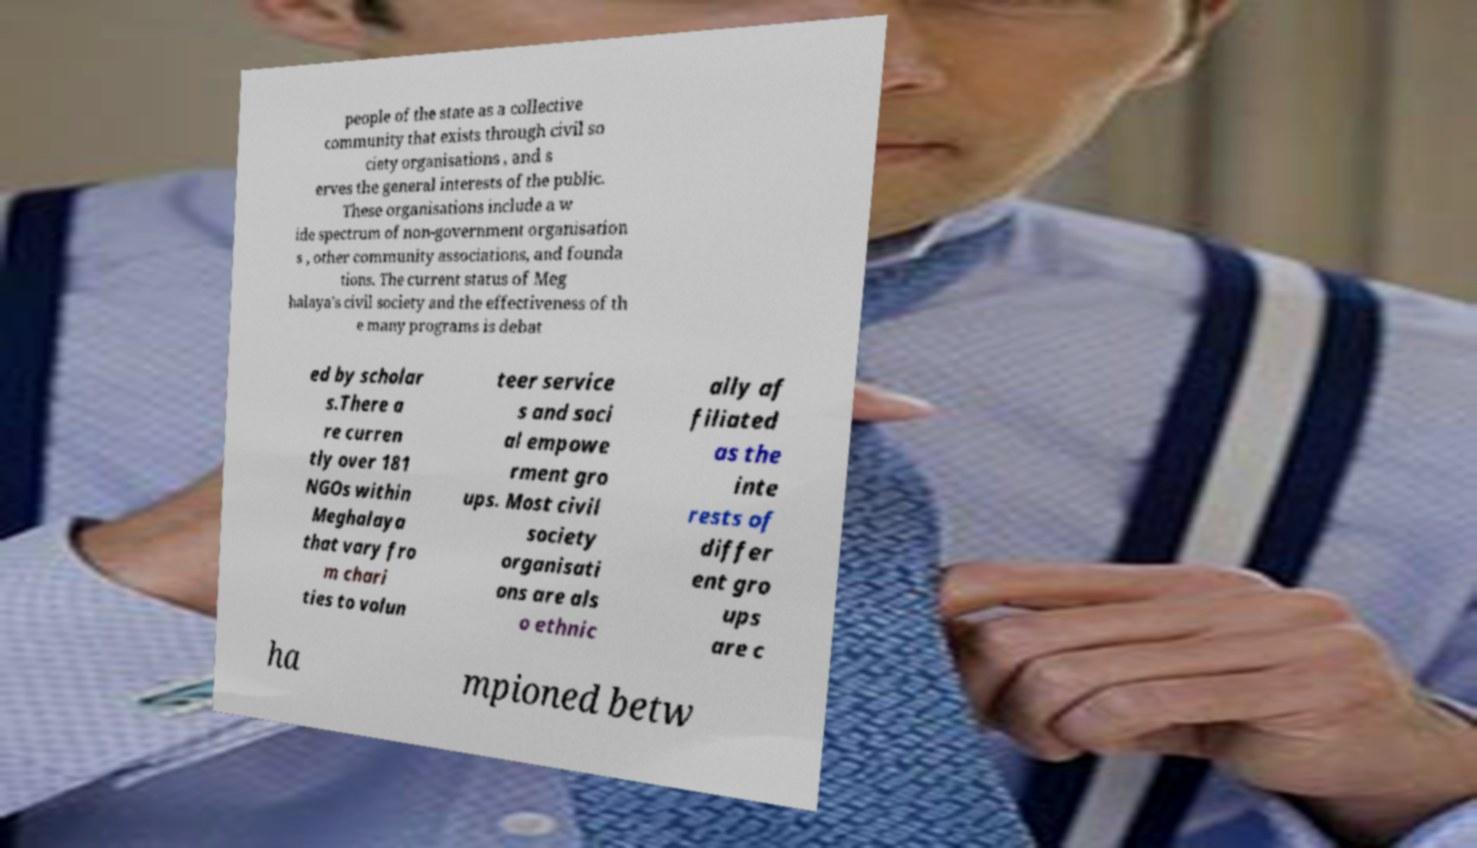Can you read and provide the text displayed in the image?This photo seems to have some interesting text. Can you extract and type it out for me? people of the state as a collective community that exists through civil so ciety organisations , and s erves the general interests of the public. These organisations include a w ide spectrum of non-government organisation s , other community associations, and founda tions. The current status of Meg halaya's civil society and the effectiveness of th e many programs is debat ed by scholar s.There a re curren tly over 181 NGOs within Meghalaya that vary fro m chari ties to volun teer service s and soci al empowe rment gro ups. Most civil society organisati ons are als o ethnic ally af filiated as the inte rests of differ ent gro ups are c ha mpioned betw 